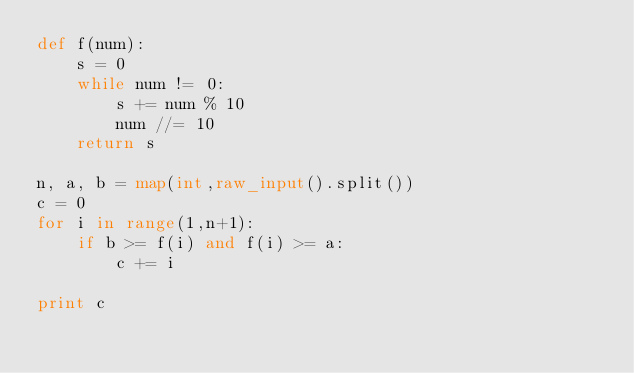<code> <loc_0><loc_0><loc_500><loc_500><_Python_>def f(num):
    s = 0
    while num != 0:
        s += num % 10
        num //= 10 
    return s

n, a, b = map(int,raw_input().split()) 
c = 0
for i in range(1,n+1):
    if b >= f(i) and f(i) >= a:
        c += i
    
print c</code> 